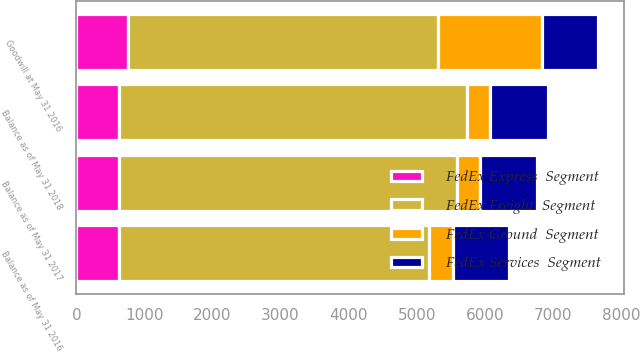Convert chart to OTSL. <chart><loc_0><loc_0><loc_500><loc_500><stacked_bar_chart><ecel><fcel>Goodwill at May 31 2016<fcel>Balance as of May 31 2016<fcel>Balance as of May 31 2017<fcel>Balance as of May 31 2018<nl><fcel>FedEx Freight  Segment<fcel>4546<fcel>4546<fcel>4953<fcel>5100<nl><fcel>FedEx Services  Segment<fcel>827<fcel>827<fcel>827<fcel>840<nl><fcel>FedEx Express  Segment<fcel>764<fcel>631<fcel>631<fcel>634<nl><fcel>FedEx Ground  Segment<fcel>1525<fcel>348<fcel>348<fcel>348<nl></chart> 